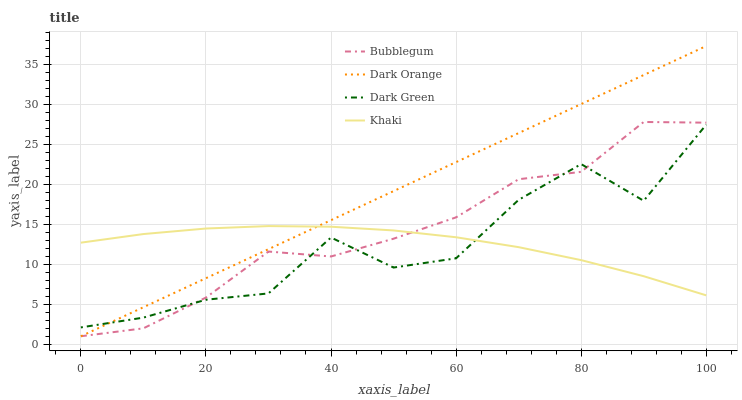Does Dark Green have the minimum area under the curve?
Answer yes or no. Yes. Does Dark Orange have the maximum area under the curve?
Answer yes or no. Yes. Does Khaki have the minimum area under the curve?
Answer yes or no. No. Does Khaki have the maximum area under the curve?
Answer yes or no. No. Is Dark Orange the smoothest?
Answer yes or no. Yes. Is Dark Green the roughest?
Answer yes or no. Yes. Is Khaki the smoothest?
Answer yes or no. No. Is Khaki the roughest?
Answer yes or no. No. Does Khaki have the lowest value?
Answer yes or no. No. Does Dark Orange have the highest value?
Answer yes or no. Yes. Does Bubblegum have the highest value?
Answer yes or no. No. Does Dark Green intersect Bubblegum?
Answer yes or no. Yes. Is Dark Green less than Bubblegum?
Answer yes or no. No. Is Dark Green greater than Bubblegum?
Answer yes or no. No. 